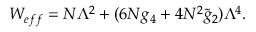<formula> <loc_0><loc_0><loc_500><loc_500>W _ { e f f } = N \Lambda ^ { 2 } + ( 6 N g _ { 4 } + 4 N ^ { 2 } \widetilde { g } _ { 2 } ) \Lambda ^ { 4 } .</formula> 